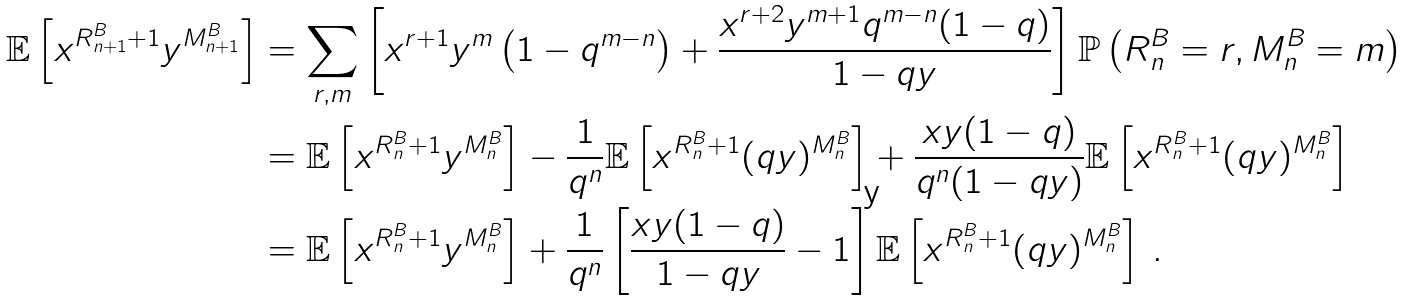<formula> <loc_0><loc_0><loc_500><loc_500>\mathbb { E } \left [ x ^ { R ^ { B } _ { n + 1 } + 1 } y ^ { M ^ { B } _ { n + 1 } } \right ] & = \sum _ { r , m } \left [ x ^ { r + 1 } y ^ { m } \left ( 1 - q ^ { m - n } \right ) + \frac { x ^ { r + 2 } y ^ { m + 1 } q ^ { m - n } ( 1 - q ) } { 1 - q y } \right ] \mathbb { P } \left ( R ^ { B } _ { n } = r , M ^ { B } _ { n } = m \right ) \\ & = \mathbb { E } \left [ x ^ { R ^ { B } _ { n } + 1 } y ^ { M ^ { B } _ { n } } \right ] - \frac { 1 } { q ^ { n } } \mathbb { E } \left [ x ^ { R ^ { B } _ { n } + 1 } ( q y ) ^ { M ^ { B } _ { n } } \right ] + \frac { x y ( 1 - q ) } { q ^ { n } ( 1 - q y ) } \mathbb { E } \left [ x ^ { R ^ { B } _ { n } + 1 } ( q y ) ^ { M ^ { B } _ { n } } \right ] \\ & = \mathbb { E } \left [ x ^ { R ^ { B } _ { n } + 1 } y ^ { M ^ { B } _ { n } } \right ] + \frac { 1 } { q ^ { n } } \left [ \frac { x y ( 1 - q ) } { 1 - q y } - 1 \right ] \mathbb { E } \left [ x ^ { R ^ { B } _ { n } + 1 } ( q y ) ^ { M ^ { B } _ { n } } \right ] \, .</formula> 